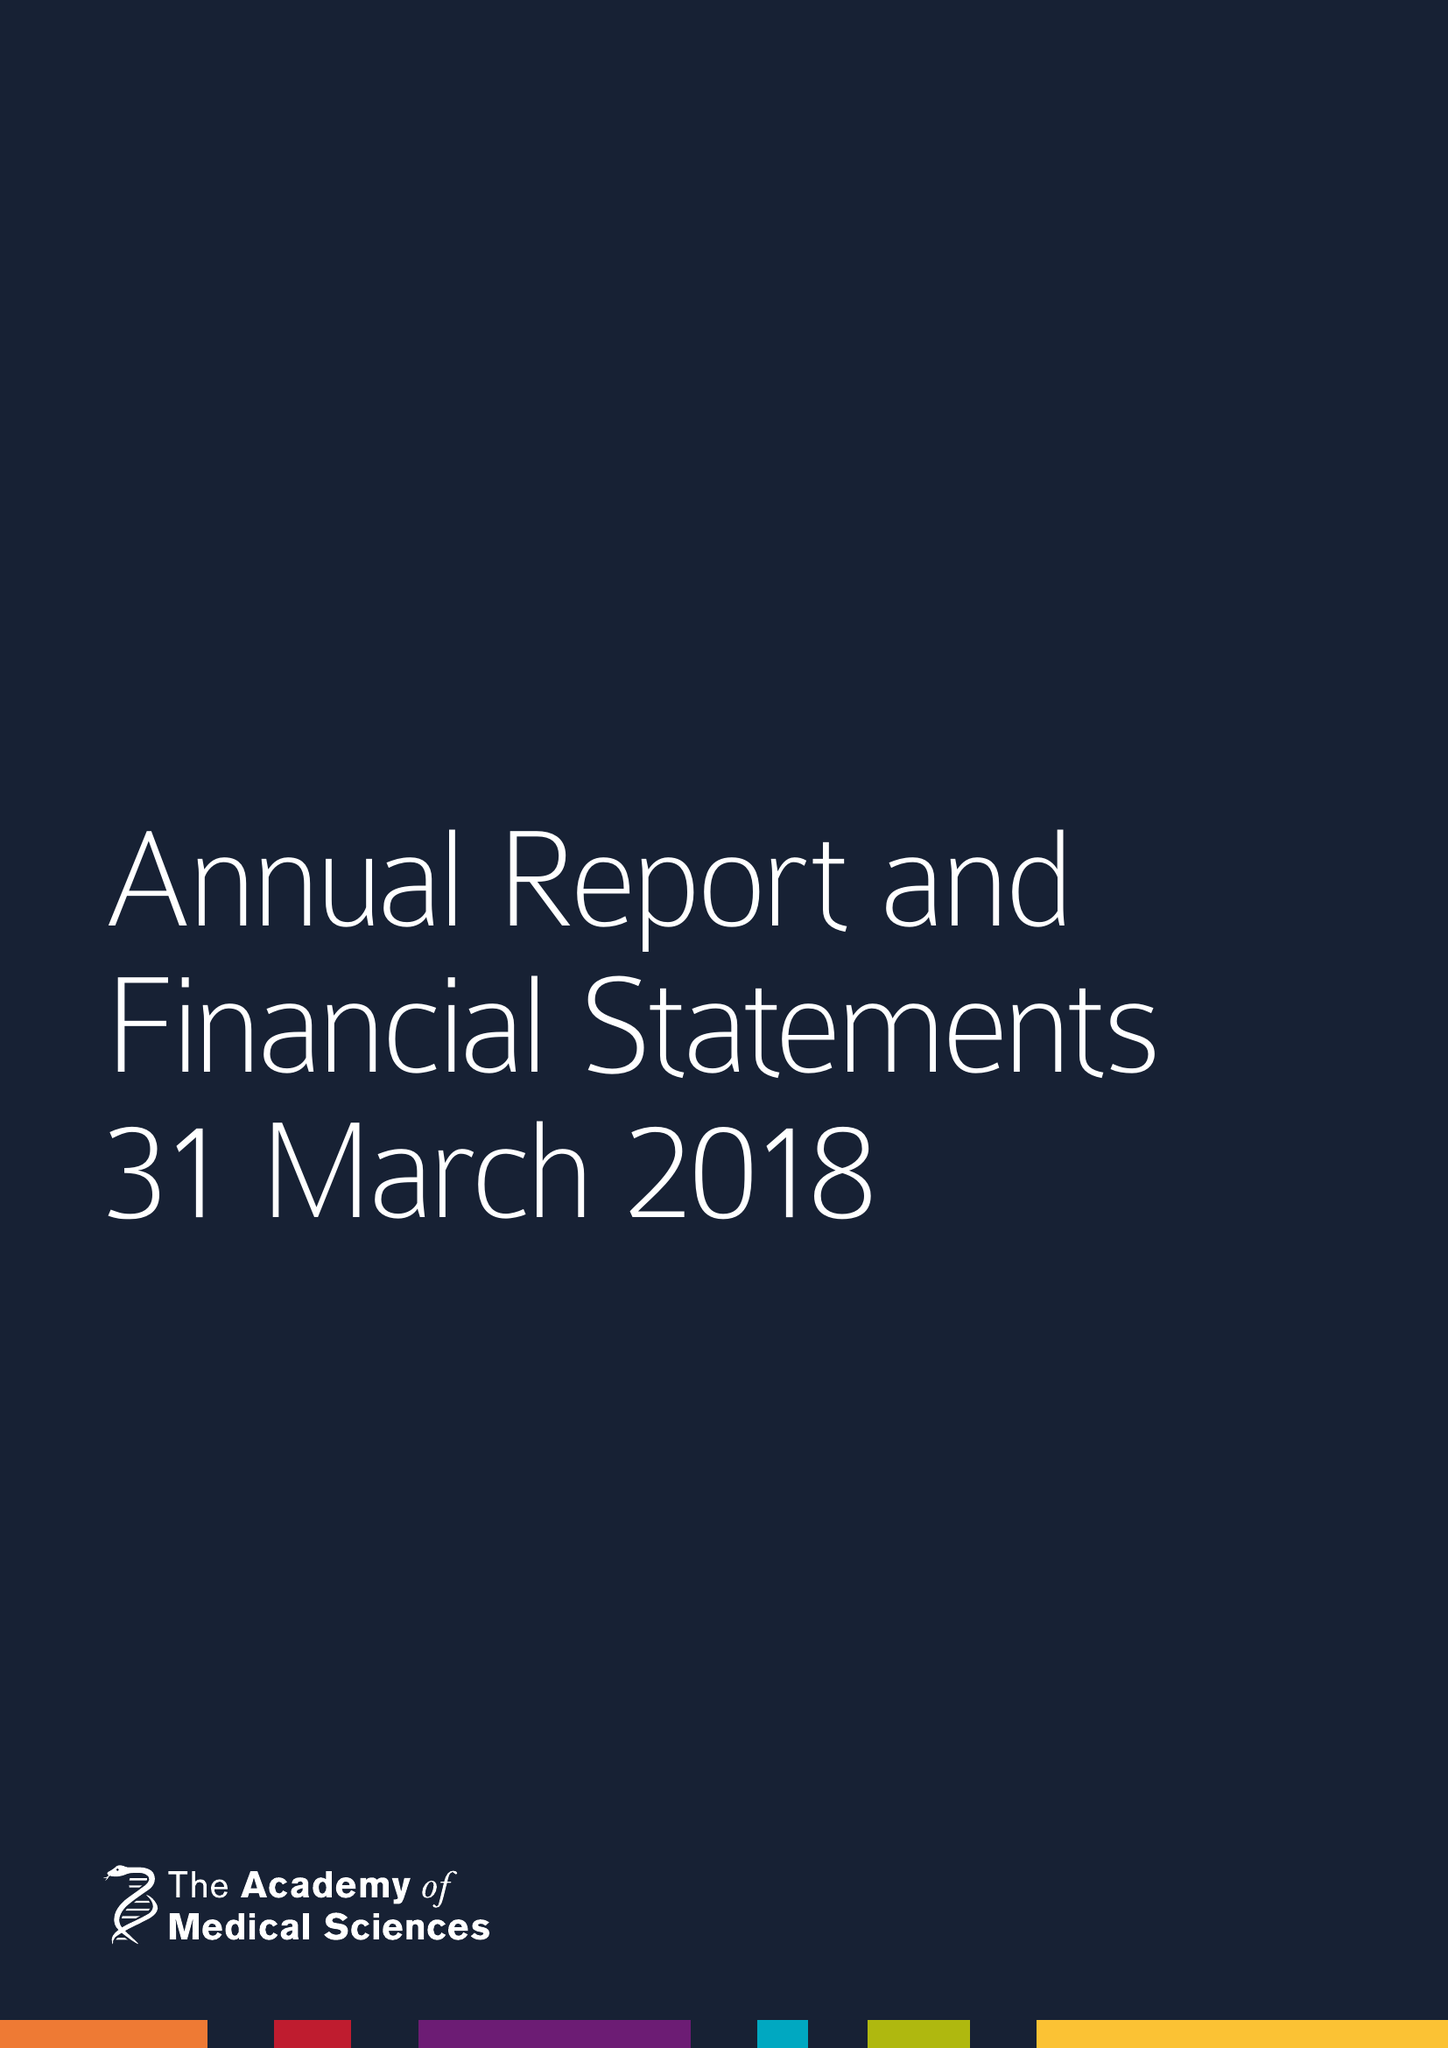What is the value for the charity_name?
Answer the question using a single word or phrase. Academy Of Medical Sciences 